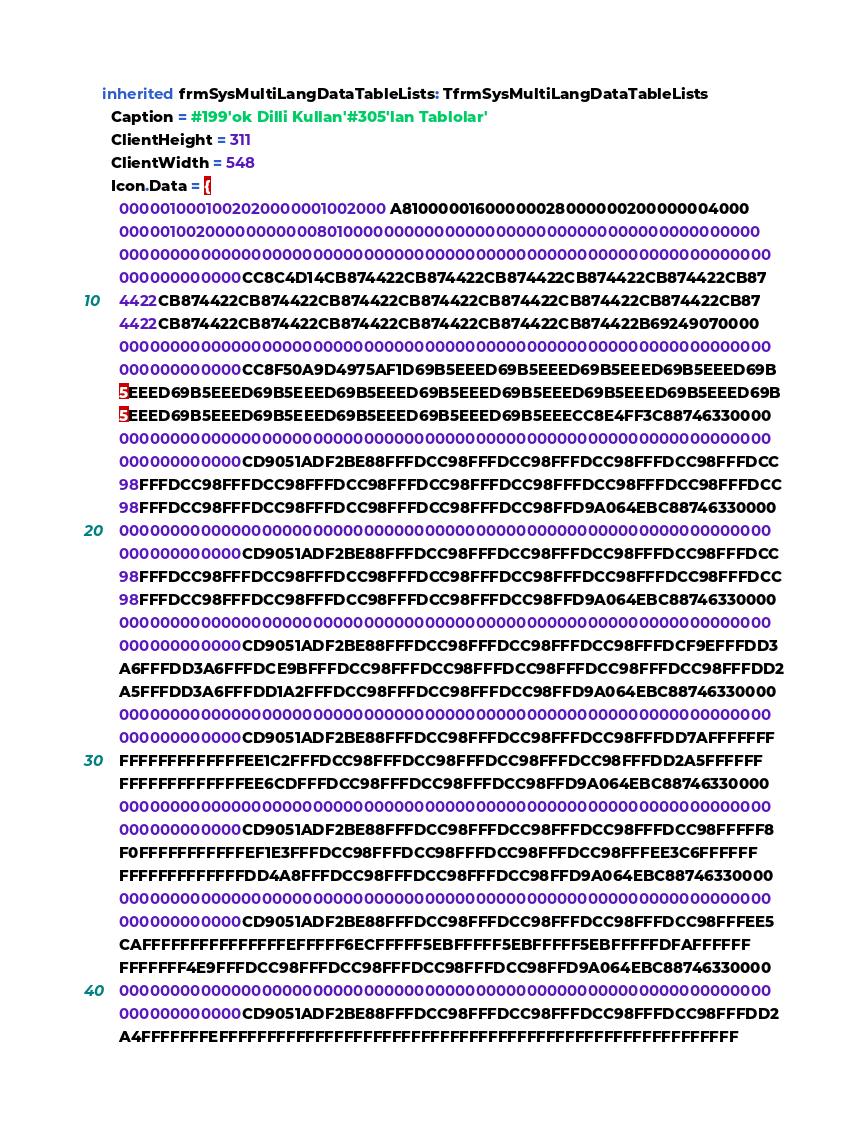Convert code to text. <code><loc_0><loc_0><loc_500><loc_500><_Pascal_>inherited frmSysMultiLangDataTableLists: TfrmSysMultiLangDataTableLists
  Caption = #199'ok Dilli Kullan'#305'lan Tablolar'
  ClientHeight = 311
  ClientWidth = 548
  Icon.Data = {
    0000010001002020000001002000A81000001600000028000000200000004000
    0000010020000000000080100000000000000000000000000000000000000000
    0000000000000000000000000000000000000000000000000000000000000000
    000000000000CC8C4D14CB874422CB874422CB874422CB874422CB874422CB87
    4422CB874422CB874422CB874422CB874422CB874422CB874422CB874422CB87
    4422CB874422CB874422CB874422CB874422CB874422CB874422B69249070000
    0000000000000000000000000000000000000000000000000000000000000000
    000000000000CC8F50A9D4975AF1D69B5EEED69B5EEED69B5EEED69B5EEED69B
    5EEED69B5EEED69B5EEED69B5EEED69B5EEED69B5EEED69B5EEED69B5EEED69B
    5EEED69B5EEED69B5EEED69B5EEED69B5EEED69B5EEECC8E4FF3C88746330000
    0000000000000000000000000000000000000000000000000000000000000000
    000000000000CD9051ADF2BE88FFFDCC98FFFDCC98FFFDCC98FFFDCC98FFFDCC
    98FFFDCC98FFFDCC98FFFDCC98FFFDCC98FFFDCC98FFFDCC98FFFDCC98FFFDCC
    98FFFDCC98FFFDCC98FFFDCC98FFFDCC98FFFDCC98FFD9A064EBC88746330000
    0000000000000000000000000000000000000000000000000000000000000000
    000000000000CD9051ADF2BE88FFFDCC98FFFDCC98FFFDCC98FFFDCC98FFFDCC
    98FFFDCC98FFFDCC98FFFDCC98FFFDCC98FFFDCC98FFFDCC98FFFDCC98FFFDCC
    98FFFDCC98FFFDCC98FFFDCC98FFFDCC98FFFDCC98FFD9A064EBC88746330000
    0000000000000000000000000000000000000000000000000000000000000000
    000000000000CD9051ADF2BE88FFFDCC98FFFDCC98FFFDCC98FFFDCF9EFFFDD3
    A6FFFDD3A6FFFDCE9BFFFDCC98FFFDCC98FFFDCC98FFFDCC98FFFDCC98FFFDD2
    A5FFFDD3A6FFFDD1A2FFFDCC98FFFDCC98FFFDCC98FFD9A064EBC88746330000
    0000000000000000000000000000000000000000000000000000000000000000
    000000000000CD9051ADF2BE88FFFDCC98FFFDCC98FFFDCC98FFFDD7AFFFFFFF
    FFFFFFFFFFFFFEE1C2FFFDCC98FFFDCC98FFFDCC98FFFDCC98FFFDD2A5FFFFFF
    FFFFFFFFFFFFFEE6CDFFFDCC98FFFDCC98FFFDCC98FFD9A064EBC88746330000
    0000000000000000000000000000000000000000000000000000000000000000
    000000000000CD9051ADF2BE88FFFDCC98FFFDCC98FFFDCC98FFFDCC98FFFFF8
    F0FFFFFFFFFFFEF1E3FFFDCC98FFFDCC98FFFDCC98FFFDCC98FFFEE3C6FFFFFF
    FFFFFFFFFFFFFDD4A8FFFDCC98FFFDCC98FFFDCC98FFD9A064EBC88746330000
    0000000000000000000000000000000000000000000000000000000000000000
    000000000000CD9051ADF2BE88FFFDCC98FFFDCC98FFFDCC98FFFDCC98FFFEE5
    CAFFFFFFFFFFFFFFFEFFFFF6ECFFFFF5EBFFFFF5EBFFFFF5EBFFFFFDFAFFFFFF
    FFFFFFF4E9FFFDCC98FFFDCC98FFFDCC98FFFDCC98FFD9A064EBC88746330000
    0000000000000000000000000000000000000000000000000000000000000000
    000000000000CD9051ADF2BE88FFFDCC98FFFDCC98FFFDCC98FFFDCC98FFFDD2
    A4FFFFFFFEFFFFFFFFFFFFFFFFFFFFFFFFFFFFFFFFFFFFFFFFFFFFFFFFFFFFFF</code> 